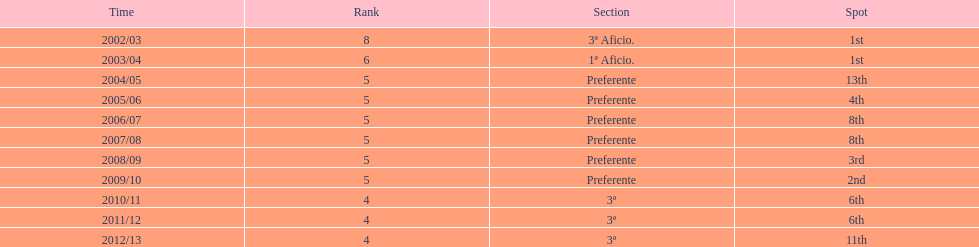How many seasons did internacional de madrid cf play in the preferente division? 6. 